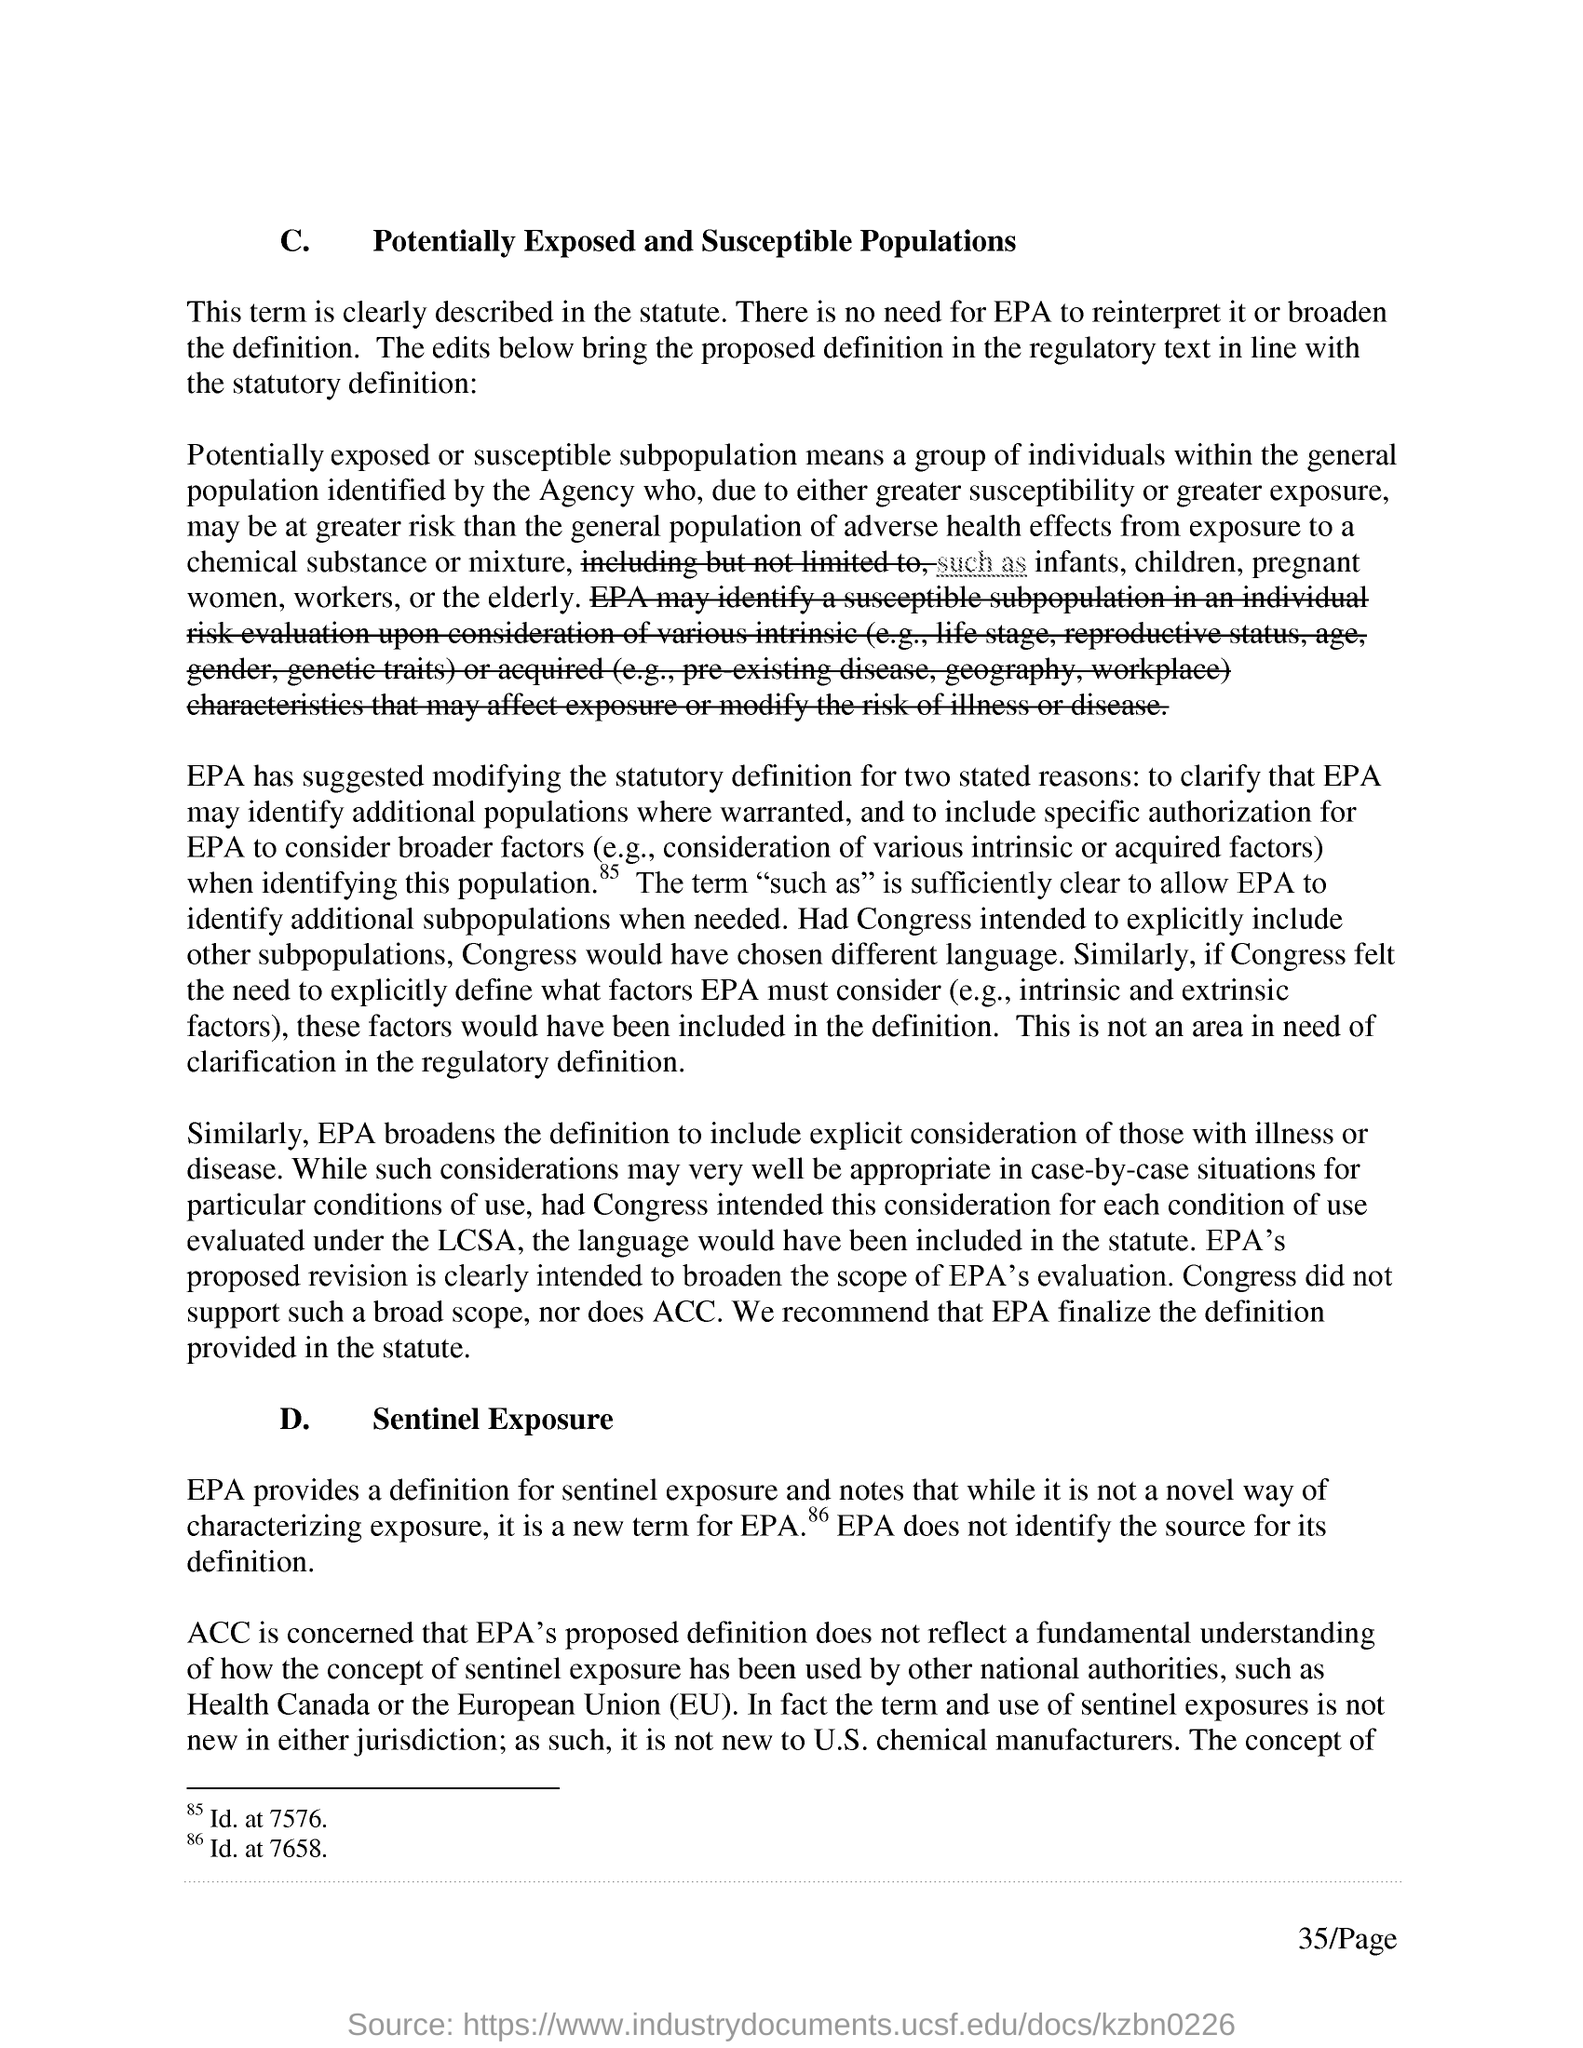What is the first title in the document?
Ensure brevity in your answer.  Potentially Exposed and Susceptible Populations. 